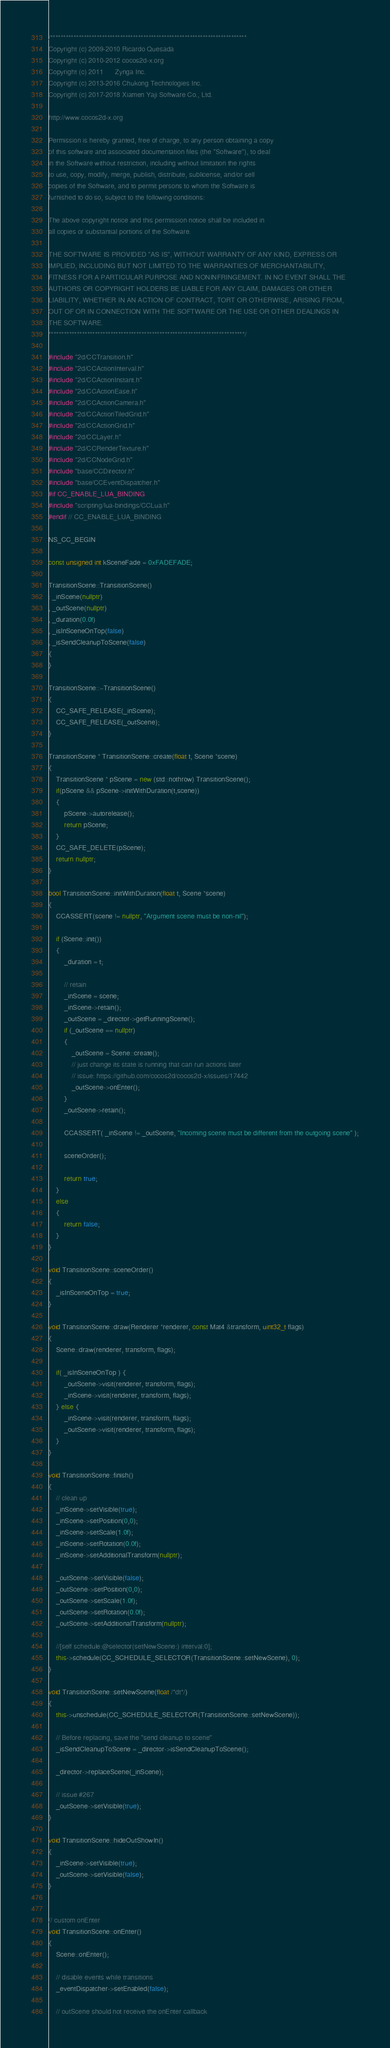<code> <loc_0><loc_0><loc_500><loc_500><_C++_>/****************************************************************************
Copyright (c) 2009-2010 Ricardo Quesada
Copyright (c) 2010-2012 cocos2d-x.org
Copyright (c) 2011      Zynga Inc.
Copyright (c) 2013-2016 Chukong Technologies Inc.
Copyright (c) 2017-2018 Xiamen Yaji Software Co., Ltd.

http://www.cocos2d-x.org

Permission is hereby granted, free of charge, to any person obtaining a copy
of this software and associated documentation files (the "Software"), to deal
in the Software without restriction, including without limitation the rights
to use, copy, modify, merge, publish, distribute, sublicense, and/or sell
copies of the Software, and to permit persons to whom the Software is
furnished to do so, subject to the following conditions:

The above copyright notice and this permission notice shall be included in
all copies or substantial portions of the Software.

THE SOFTWARE IS PROVIDED "AS IS", WITHOUT WARRANTY OF ANY KIND, EXPRESS OR
IMPLIED, INCLUDING BUT NOT LIMITED TO THE WARRANTIES OF MERCHANTABILITY,
FITNESS FOR A PARTICULAR PURPOSE AND NONINFRINGEMENT. IN NO EVENT SHALL THE
AUTHORS OR COPYRIGHT HOLDERS BE LIABLE FOR ANY CLAIM, DAMAGES OR OTHER
LIABILITY, WHETHER IN AN ACTION OF CONTRACT, TORT OR OTHERWISE, ARISING FROM,
OUT OF OR IN CONNECTION WITH THE SOFTWARE OR THE USE OR OTHER DEALINGS IN
THE SOFTWARE.
****************************************************************************/

#include "2d/CCTransition.h"
#include "2d/CCActionInterval.h"
#include "2d/CCActionInstant.h"
#include "2d/CCActionEase.h"
#include "2d/CCActionCamera.h"
#include "2d/CCActionTiledGrid.h"
#include "2d/CCActionGrid.h"
#include "2d/CCLayer.h"
#include "2d/CCRenderTexture.h"
#include "2d/CCNodeGrid.h"
#include "base/CCDirector.h"
#include "base/CCEventDispatcher.h"
#if CC_ENABLE_LUA_BINDING
#include "scripting/lua-bindings/CCLua.h"
#endif // CC_ENABLE_LUA_BINDING

NS_CC_BEGIN

const unsigned int kSceneFade = 0xFADEFADE;

TransitionScene::TransitionScene()
: _inScene(nullptr)
, _outScene(nullptr)
, _duration(0.0f)
, _isInSceneOnTop(false)
, _isSendCleanupToScene(false)
{
}

TransitionScene::~TransitionScene()
{
    CC_SAFE_RELEASE(_inScene);
    CC_SAFE_RELEASE(_outScene);
}

TransitionScene * TransitionScene::create(float t, Scene *scene)
{
    TransitionScene * pScene = new (std::nothrow) TransitionScene();
    if(pScene && pScene->initWithDuration(t,scene))
    {
        pScene->autorelease();
        return pScene;
    }
    CC_SAFE_DELETE(pScene);
    return nullptr;
}

bool TransitionScene::initWithDuration(float t, Scene *scene)
{
    CCASSERT(scene != nullptr, "Argument scene must be non-nil");

    if (Scene::init())
    {
        _duration = t;

        // retain
        _inScene = scene;
        _inScene->retain();
        _outScene = _director->getRunningScene();
        if (_outScene == nullptr)
        {
            _outScene = Scene::create();
            // just change its state is running that can run actions later
            // issue: https://github.com/cocos2d/cocos2d-x/issues/17442
            _outScene->onEnter();
        }
        _outScene->retain();

        CCASSERT( _inScene != _outScene, "Incoming scene must be different from the outgoing scene" );
        
        sceneOrder();

        return true;
    }
    else
    {
        return false;
    }
}

void TransitionScene::sceneOrder()
{
    _isInSceneOnTop = true;
}

void TransitionScene::draw(Renderer *renderer, const Mat4 &transform, uint32_t flags)
{
    Scene::draw(renderer, transform, flags);

    if( _isInSceneOnTop ) {
        _outScene->visit(renderer, transform, flags);
        _inScene->visit(renderer, transform, flags);
    } else {
        _inScene->visit(renderer, transform, flags);
        _outScene->visit(renderer, transform, flags);
    }
}

void TransitionScene::finish()
{
    // clean up
    _inScene->setVisible(true);
    _inScene->setPosition(0,0);
    _inScene->setScale(1.0f);
    _inScene->setRotation(0.0f);
    _inScene->setAdditionalTransform(nullptr);

    _outScene->setVisible(false);
    _outScene->setPosition(0,0);
    _outScene->setScale(1.0f);
    _outScene->setRotation(0.0f);
    _outScene->setAdditionalTransform(nullptr);

    //[self schedule:@selector(setNewScene:) interval:0];
    this->schedule(CC_SCHEDULE_SELECTOR(TransitionScene::setNewScene), 0);
}

void TransitionScene::setNewScene(float /*dt*/)
{    
    this->unschedule(CC_SCHEDULE_SELECTOR(TransitionScene::setNewScene));
    
    // Before replacing, save the "send cleanup to scene"
    _isSendCleanupToScene = _director->isSendCleanupToScene();
    
    _director->replaceScene(_inScene);
    
    // issue #267
    _outScene->setVisible(true);
}

void TransitionScene::hideOutShowIn()
{
    _inScene->setVisible(true);
    _outScene->setVisible(false);
}


// custom onEnter
void TransitionScene::onEnter()
{
    Scene::onEnter();
    
    // disable events while transitions
    _eventDispatcher->setEnabled(false);
    
    // outScene should not receive the onEnter callback</code> 